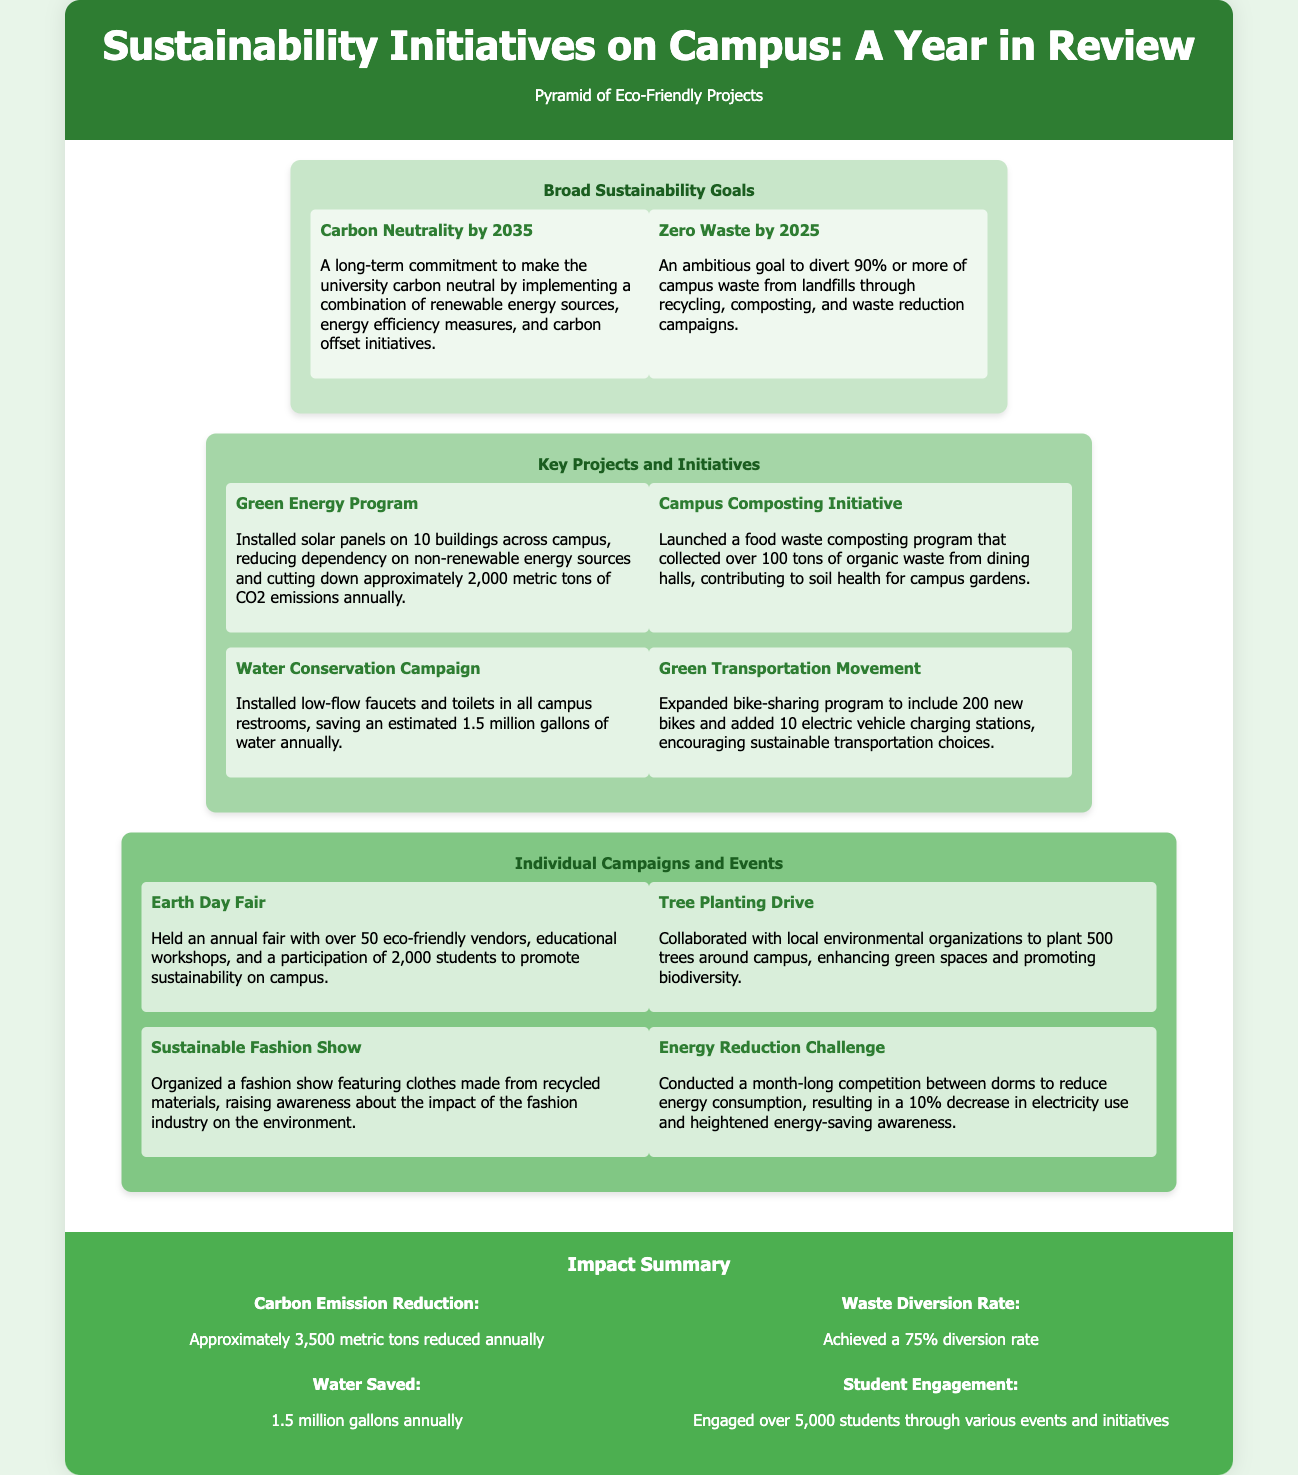What is the broad sustainability goal for 2035? The broad sustainability goal for 2035 is carbon neutrality.
Answer: Carbon Neutrality by 2035 How many tons of CO2 emissions does the Green Energy Program reduce annually? The Green Energy Program reduces approximately 2,000 metric tons of CO2 emissions annually.
Answer: 2,000 metric tons What is the waste diversion rate achieved? The achieved waste diversion rate is 75%.
Answer: 75% How many students participated in the Earth Day Fair? The Earth Day Fair saw participation from 2,000 students.
Answer: 2,000 students How many trees were planted during the Tree Planting Drive? The Tree Planting Drive resulted in the planting of 500 trees.
Answer: 500 trees What eco-friendly project encourages sustainable transportation? The project that encourages sustainable transportation is the Green Transportation Movement.
Answer: Green Transportation Movement What was the impact on energy consumption from the Energy Reduction Challenge? The Energy Reduction Challenge resulted in a 10% decrease in electricity use.
Answer: 10% How many eco-friendly vendors were present at the Earth Day Fair? There were over 50 eco-friendly vendors at the Earth Day Fair.
Answer: 50 vendors Which initiative saved an estimated 1.5 million gallons of water annually? The initiative that saved an estimated 1.5 million gallons of water annually is the Water Conservation Campaign.
Answer: Water Conservation Campaign 